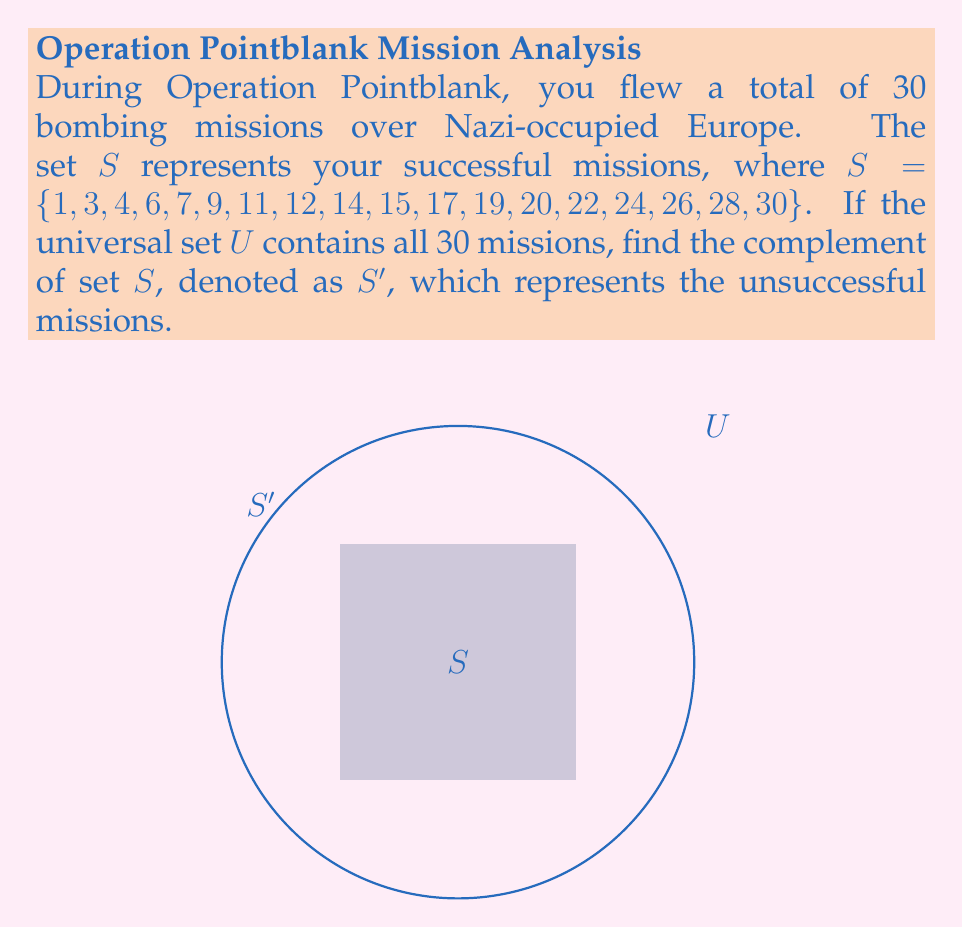Give your solution to this math problem. To find the complement of set $S$, we need to identify all elements in the universal set $U$ that are not in set $S$. Let's approach this step-by-step:

1) First, let's define our universal set $U$:
   $U = \{1, 2, 3, ..., 29, 30\}$

2) We're given set $S$:
   $S = \{1, 3, 4, 6, 7, 9, 11, 12, 14, 15, 17, 19, 20, 22, 24, 26, 28, 30\}$

3) The complement of $S$, denoted as $S'$, will contain all elements in $U$ that are not in $S$. We can find these by listing the numbers from 1 to 30 that are not in $S$:

4) $S' = \{2, 5, 8, 10, 13, 16, 18, 21, 23, 25, 27, 29\}$

5) We can verify our answer by checking:
   - All elements in $S'$ are in $U$
   - No element in $S'$ is in $S$
   - $|S| + |S'| = 18 + 12 = 30 = |U|$

Therefore, the set $S'$ represents your unsuccessful bombing missions during Operation Pointblank.
Answer: $S' = \{2, 5, 8, 10, 13, 16, 18, 21, 23, 25, 27, 29\}$ 